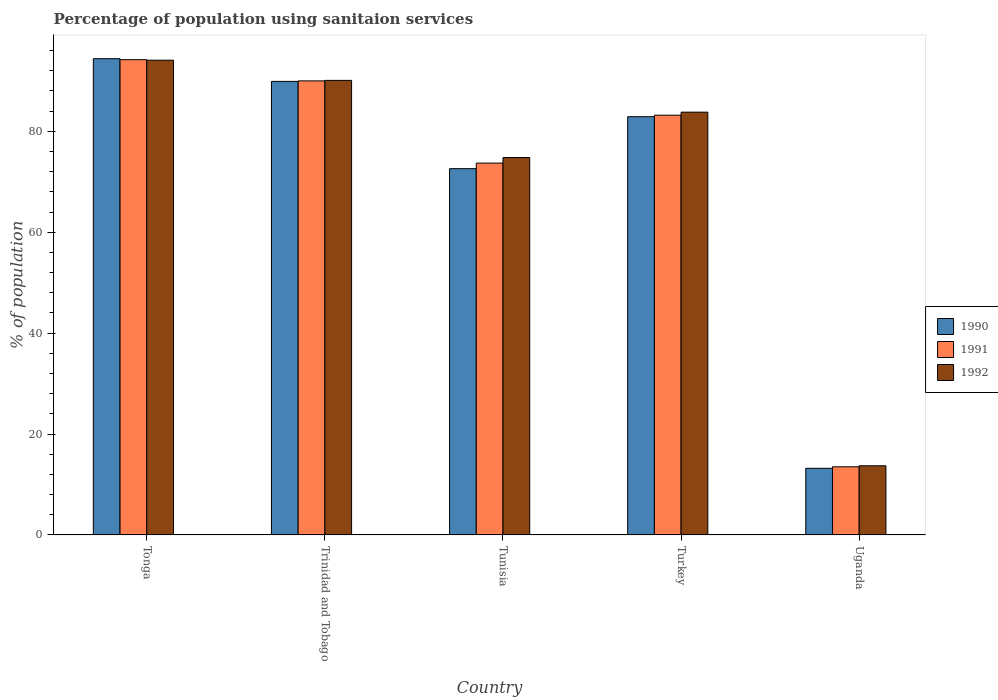How many different coloured bars are there?
Offer a very short reply. 3. How many groups of bars are there?
Offer a terse response. 5. Are the number of bars per tick equal to the number of legend labels?
Give a very brief answer. Yes. Are the number of bars on each tick of the X-axis equal?
Your answer should be compact. Yes. How many bars are there on the 4th tick from the right?
Keep it short and to the point. 3. What is the label of the 4th group of bars from the left?
Provide a short and direct response. Turkey. In how many cases, is the number of bars for a given country not equal to the number of legend labels?
Provide a succinct answer. 0. What is the percentage of population using sanitaion services in 1992 in Tonga?
Give a very brief answer. 94.1. Across all countries, what is the maximum percentage of population using sanitaion services in 1990?
Keep it short and to the point. 94.4. In which country was the percentage of population using sanitaion services in 1990 maximum?
Offer a terse response. Tonga. In which country was the percentage of population using sanitaion services in 1992 minimum?
Your response must be concise. Uganda. What is the total percentage of population using sanitaion services in 1991 in the graph?
Give a very brief answer. 354.6. What is the difference between the percentage of population using sanitaion services in 1990 in Tunisia and that in Turkey?
Your answer should be very brief. -10.3. What is the difference between the percentage of population using sanitaion services in 1991 in Tonga and the percentage of population using sanitaion services in 1990 in Uganda?
Make the answer very short. 81. What is the average percentage of population using sanitaion services in 1990 per country?
Your answer should be very brief. 70.6. What is the difference between the percentage of population using sanitaion services of/in 1991 and percentage of population using sanitaion services of/in 1990 in Trinidad and Tobago?
Offer a very short reply. 0.1. What is the ratio of the percentage of population using sanitaion services in 1992 in Tunisia to that in Turkey?
Provide a succinct answer. 0.89. Is the percentage of population using sanitaion services in 1990 in Turkey less than that in Uganda?
Provide a short and direct response. No. Is the difference between the percentage of population using sanitaion services in 1991 in Tonga and Uganda greater than the difference between the percentage of population using sanitaion services in 1990 in Tonga and Uganda?
Make the answer very short. No. What is the difference between the highest and the second highest percentage of population using sanitaion services in 1991?
Offer a terse response. 6.8. What is the difference between the highest and the lowest percentage of population using sanitaion services in 1990?
Your answer should be compact. 81.2. In how many countries, is the percentage of population using sanitaion services in 1991 greater than the average percentage of population using sanitaion services in 1991 taken over all countries?
Ensure brevity in your answer.  4. Is it the case that in every country, the sum of the percentage of population using sanitaion services in 1991 and percentage of population using sanitaion services in 1992 is greater than the percentage of population using sanitaion services in 1990?
Offer a very short reply. Yes. How many bars are there?
Provide a short and direct response. 15. What is the difference between two consecutive major ticks on the Y-axis?
Provide a short and direct response. 20. Does the graph contain grids?
Make the answer very short. No. How many legend labels are there?
Make the answer very short. 3. What is the title of the graph?
Offer a very short reply. Percentage of population using sanitaion services. Does "1997" appear as one of the legend labels in the graph?
Your answer should be compact. No. What is the label or title of the Y-axis?
Keep it short and to the point. % of population. What is the % of population in 1990 in Tonga?
Your answer should be compact. 94.4. What is the % of population in 1991 in Tonga?
Provide a succinct answer. 94.2. What is the % of population of 1992 in Tonga?
Provide a succinct answer. 94.1. What is the % of population of 1990 in Trinidad and Tobago?
Keep it short and to the point. 89.9. What is the % of population of 1991 in Trinidad and Tobago?
Your answer should be compact. 90. What is the % of population in 1992 in Trinidad and Tobago?
Offer a very short reply. 90.1. What is the % of population of 1990 in Tunisia?
Keep it short and to the point. 72.6. What is the % of population in 1991 in Tunisia?
Your answer should be compact. 73.7. What is the % of population in 1992 in Tunisia?
Make the answer very short. 74.8. What is the % of population in 1990 in Turkey?
Provide a succinct answer. 82.9. What is the % of population of 1991 in Turkey?
Provide a short and direct response. 83.2. What is the % of population of 1992 in Turkey?
Make the answer very short. 83.8. Across all countries, what is the maximum % of population in 1990?
Provide a short and direct response. 94.4. Across all countries, what is the maximum % of population of 1991?
Your response must be concise. 94.2. Across all countries, what is the maximum % of population of 1992?
Your answer should be very brief. 94.1. Across all countries, what is the minimum % of population of 1992?
Provide a succinct answer. 13.7. What is the total % of population in 1990 in the graph?
Offer a very short reply. 353. What is the total % of population in 1991 in the graph?
Provide a short and direct response. 354.6. What is the total % of population of 1992 in the graph?
Your answer should be very brief. 356.5. What is the difference between the % of population in 1990 in Tonga and that in Trinidad and Tobago?
Provide a short and direct response. 4.5. What is the difference between the % of population in 1990 in Tonga and that in Tunisia?
Provide a short and direct response. 21.8. What is the difference between the % of population in 1991 in Tonga and that in Tunisia?
Provide a short and direct response. 20.5. What is the difference between the % of population in 1992 in Tonga and that in Tunisia?
Your answer should be very brief. 19.3. What is the difference between the % of population in 1990 in Tonga and that in Turkey?
Offer a very short reply. 11.5. What is the difference between the % of population in 1992 in Tonga and that in Turkey?
Provide a short and direct response. 10.3. What is the difference between the % of population in 1990 in Tonga and that in Uganda?
Your answer should be compact. 81.2. What is the difference between the % of population of 1991 in Tonga and that in Uganda?
Make the answer very short. 80.7. What is the difference between the % of population of 1992 in Tonga and that in Uganda?
Your answer should be very brief. 80.4. What is the difference between the % of population of 1991 in Trinidad and Tobago and that in Tunisia?
Provide a short and direct response. 16.3. What is the difference between the % of population of 1990 in Trinidad and Tobago and that in Turkey?
Offer a very short reply. 7. What is the difference between the % of population of 1991 in Trinidad and Tobago and that in Turkey?
Give a very brief answer. 6.8. What is the difference between the % of population of 1990 in Trinidad and Tobago and that in Uganda?
Make the answer very short. 76.7. What is the difference between the % of population of 1991 in Trinidad and Tobago and that in Uganda?
Make the answer very short. 76.5. What is the difference between the % of population in 1992 in Trinidad and Tobago and that in Uganda?
Keep it short and to the point. 76.4. What is the difference between the % of population of 1990 in Tunisia and that in Turkey?
Offer a terse response. -10.3. What is the difference between the % of population in 1991 in Tunisia and that in Turkey?
Offer a very short reply. -9.5. What is the difference between the % of population of 1992 in Tunisia and that in Turkey?
Provide a short and direct response. -9. What is the difference between the % of population of 1990 in Tunisia and that in Uganda?
Offer a terse response. 59.4. What is the difference between the % of population of 1991 in Tunisia and that in Uganda?
Make the answer very short. 60.2. What is the difference between the % of population of 1992 in Tunisia and that in Uganda?
Offer a very short reply. 61.1. What is the difference between the % of population of 1990 in Turkey and that in Uganda?
Your answer should be compact. 69.7. What is the difference between the % of population of 1991 in Turkey and that in Uganda?
Offer a very short reply. 69.7. What is the difference between the % of population of 1992 in Turkey and that in Uganda?
Your answer should be compact. 70.1. What is the difference between the % of population in 1990 in Tonga and the % of population in 1991 in Trinidad and Tobago?
Provide a short and direct response. 4.4. What is the difference between the % of population in 1990 in Tonga and the % of population in 1992 in Trinidad and Tobago?
Offer a terse response. 4.3. What is the difference between the % of population of 1991 in Tonga and the % of population of 1992 in Trinidad and Tobago?
Your answer should be very brief. 4.1. What is the difference between the % of population in 1990 in Tonga and the % of population in 1991 in Tunisia?
Your answer should be compact. 20.7. What is the difference between the % of population of 1990 in Tonga and the % of population of 1992 in Tunisia?
Your response must be concise. 19.6. What is the difference between the % of population of 1991 in Tonga and the % of population of 1992 in Tunisia?
Keep it short and to the point. 19.4. What is the difference between the % of population of 1990 in Tonga and the % of population of 1991 in Turkey?
Your answer should be very brief. 11.2. What is the difference between the % of population of 1991 in Tonga and the % of population of 1992 in Turkey?
Provide a short and direct response. 10.4. What is the difference between the % of population of 1990 in Tonga and the % of population of 1991 in Uganda?
Offer a very short reply. 80.9. What is the difference between the % of population of 1990 in Tonga and the % of population of 1992 in Uganda?
Keep it short and to the point. 80.7. What is the difference between the % of population in 1991 in Tonga and the % of population in 1992 in Uganda?
Provide a succinct answer. 80.5. What is the difference between the % of population in 1990 in Trinidad and Tobago and the % of population in 1991 in Tunisia?
Make the answer very short. 16.2. What is the difference between the % of population of 1990 in Trinidad and Tobago and the % of population of 1992 in Tunisia?
Ensure brevity in your answer.  15.1. What is the difference between the % of population of 1990 in Trinidad and Tobago and the % of population of 1991 in Turkey?
Offer a terse response. 6.7. What is the difference between the % of population in 1991 in Trinidad and Tobago and the % of population in 1992 in Turkey?
Offer a very short reply. 6.2. What is the difference between the % of population in 1990 in Trinidad and Tobago and the % of population in 1991 in Uganda?
Your answer should be very brief. 76.4. What is the difference between the % of population of 1990 in Trinidad and Tobago and the % of population of 1992 in Uganda?
Ensure brevity in your answer.  76.2. What is the difference between the % of population of 1991 in Trinidad and Tobago and the % of population of 1992 in Uganda?
Give a very brief answer. 76.3. What is the difference between the % of population in 1990 in Tunisia and the % of population in 1991 in Turkey?
Ensure brevity in your answer.  -10.6. What is the difference between the % of population in 1990 in Tunisia and the % of population in 1991 in Uganda?
Provide a succinct answer. 59.1. What is the difference between the % of population of 1990 in Tunisia and the % of population of 1992 in Uganda?
Provide a short and direct response. 58.9. What is the difference between the % of population in 1990 in Turkey and the % of population in 1991 in Uganda?
Your response must be concise. 69.4. What is the difference between the % of population in 1990 in Turkey and the % of population in 1992 in Uganda?
Keep it short and to the point. 69.2. What is the difference between the % of population of 1991 in Turkey and the % of population of 1992 in Uganda?
Provide a short and direct response. 69.5. What is the average % of population in 1990 per country?
Provide a succinct answer. 70.6. What is the average % of population in 1991 per country?
Your answer should be compact. 70.92. What is the average % of population in 1992 per country?
Offer a terse response. 71.3. What is the difference between the % of population of 1990 and % of population of 1991 in Tonga?
Give a very brief answer. 0.2. What is the difference between the % of population of 1990 and % of population of 1992 in Tonga?
Offer a terse response. 0.3. What is the difference between the % of population of 1990 and % of population of 1991 in Tunisia?
Your response must be concise. -1.1. What is the difference between the % of population of 1991 and % of population of 1992 in Tunisia?
Provide a succinct answer. -1.1. What is the difference between the % of population of 1990 and % of population of 1991 in Turkey?
Ensure brevity in your answer.  -0.3. What is the difference between the % of population in 1990 and % of population in 1991 in Uganda?
Ensure brevity in your answer.  -0.3. What is the difference between the % of population of 1990 and % of population of 1992 in Uganda?
Offer a terse response. -0.5. What is the ratio of the % of population of 1990 in Tonga to that in Trinidad and Tobago?
Give a very brief answer. 1.05. What is the ratio of the % of population of 1991 in Tonga to that in Trinidad and Tobago?
Ensure brevity in your answer.  1.05. What is the ratio of the % of population of 1992 in Tonga to that in Trinidad and Tobago?
Provide a short and direct response. 1.04. What is the ratio of the % of population in 1990 in Tonga to that in Tunisia?
Your answer should be compact. 1.3. What is the ratio of the % of population of 1991 in Tonga to that in Tunisia?
Your response must be concise. 1.28. What is the ratio of the % of population of 1992 in Tonga to that in Tunisia?
Your response must be concise. 1.26. What is the ratio of the % of population of 1990 in Tonga to that in Turkey?
Your response must be concise. 1.14. What is the ratio of the % of population in 1991 in Tonga to that in Turkey?
Your answer should be very brief. 1.13. What is the ratio of the % of population in 1992 in Tonga to that in Turkey?
Offer a very short reply. 1.12. What is the ratio of the % of population of 1990 in Tonga to that in Uganda?
Keep it short and to the point. 7.15. What is the ratio of the % of population in 1991 in Tonga to that in Uganda?
Your answer should be compact. 6.98. What is the ratio of the % of population in 1992 in Tonga to that in Uganda?
Provide a succinct answer. 6.87. What is the ratio of the % of population of 1990 in Trinidad and Tobago to that in Tunisia?
Your response must be concise. 1.24. What is the ratio of the % of population of 1991 in Trinidad and Tobago to that in Tunisia?
Provide a succinct answer. 1.22. What is the ratio of the % of population in 1992 in Trinidad and Tobago to that in Tunisia?
Provide a short and direct response. 1.2. What is the ratio of the % of population of 1990 in Trinidad and Tobago to that in Turkey?
Your answer should be compact. 1.08. What is the ratio of the % of population in 1991 in Trinidad and Tobago to that in Turkey?
Ensure brevity in your answer.  1.08. What is the ratio of the % of population in 1992 in Trinidad and Tobago to that in Turkey?
Provide a succinct answer. 1.08. What is the ratio of the % of population of 1990 in Trinidad and Tobago to that in Uganda?
Give a very brief answer. 6.81. What is the ratio of the % of population in 1991 in Trinidad and Tobago to that in Uganda?
Your answer should be compact. 6.67. What is the ratio of the % of population of 1992 in Trinidad and Tobago to that in Uganda?
Your answer should be very brief. 6.58. What is the ratio of the % of population of 1990 in Tunisia to that in Turkey?
Ensure brevity in your answer.  0.88. What is the ratio of the % of population in 1991 in Tunisia to that in Turkey?
Provide a succinct answer. 0.89. What is the ratio of the % of population of 1992 in Tunisia to that in Turkey?
Ensure brevity in your answer.  0.89. What is the ratio of the % of population of 1991 in Tunisia to that in Uganda?
Your answer should be compact. 5.46. What is the ratio of the % of population of 1992 in Tunisia to that in Uganda?
Your response must be concise. 5.46. What is the ratio of the % of population in 1990 in Turkey to that in Uganda?
Offer a terse response. 6.28. What is the ratio of the % of population of 1991 in Turkey to that in Uganda?
Make the answer very short. 6.16. What is the ratio of the % of population in 1992 in Turkey to that in Uganda?
Your answer should be very brief. 6.12. What is the difference between the highest and the second highest % of population of 1991?
Your answer should be compact. 4.2. What is the difference between the highest and the lowest % of population of 1990?
Offer a very short reply. 81.2. What is the difference between the highest and the lowest % of population of 1991?
Your answer should be compact. 80.7. What is the difference between the highest and the lowest % of population of 1992?
Give a very brief answer. 80.4. 